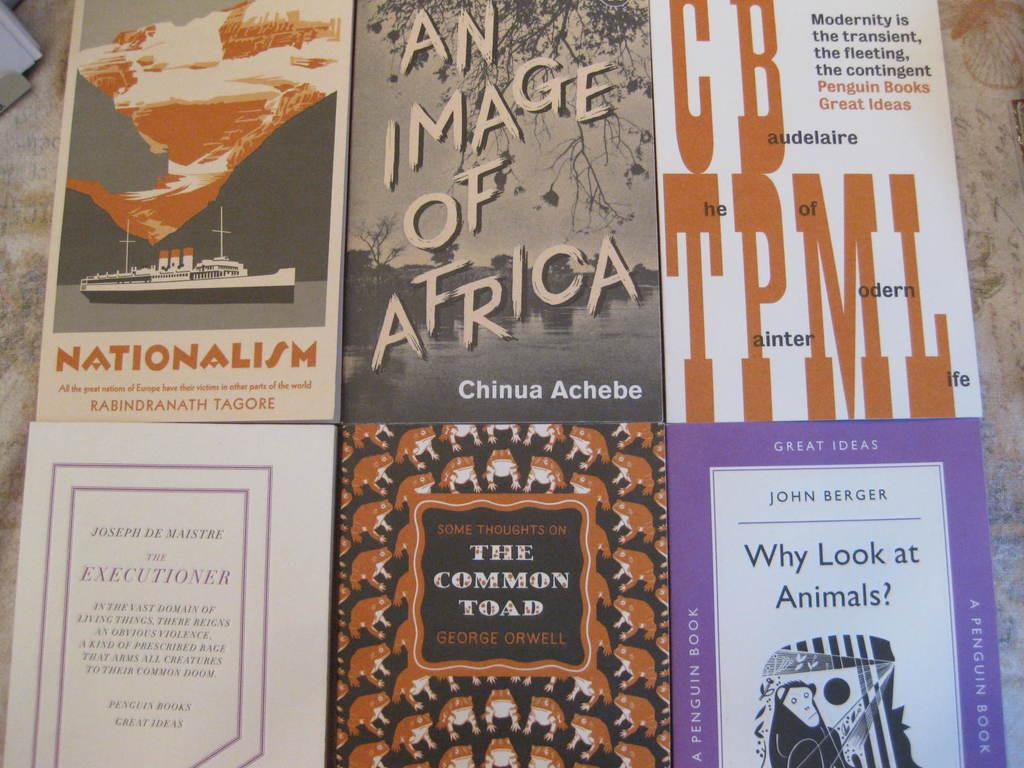<image>
Relay a brief, clear account of the picture shown. The common Toad book is on the bottom in the middle by George Orwell. 